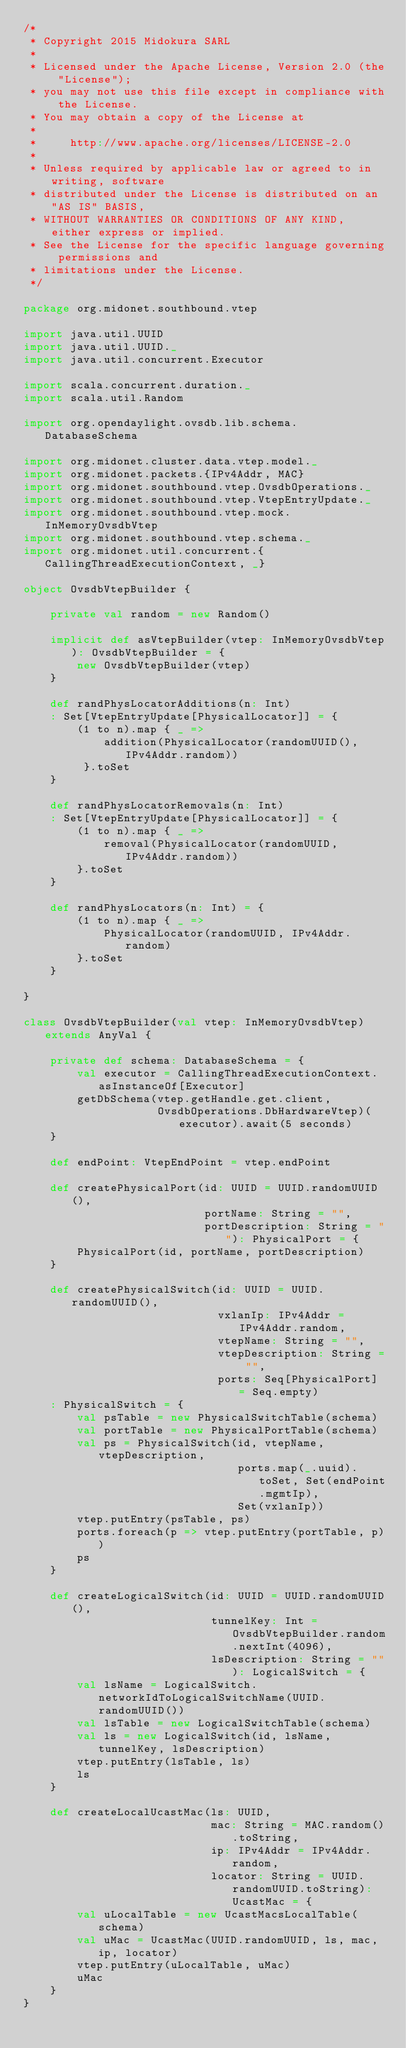Convert code to text. <code><loc_0><loc_0><loc_500><loc_500><_Scala_>/*
 * Copyright 2015 Midokura SARL
 *
 * Licensed under the Apache License, Version 2.0 (the "License");
 * you may not use this file except in compliance with the License.
 * You may obtain a copy of the License at
 *
 *     http://www.apache.org/licenses/LICENSE-2.0
 *
 * Unless required by applicable law or agreed to in writing, software
 * distributed under the License is distributed on an "AS IS" BASIS,
 * WITHOUT WARRANTIES OR CONDITIONS OF ANY KIND, either express or implied.
 * See the License for the specific language governing permissions and
 * limitations under the License.
 */

package org.midonet.southbound.vtep

import java.util.UUID
import java.util.UUID._
import java.util.concurrent.Executor

import scala.concurrent.duration._
import scala.util.Random

import org.opendaylight.ovsdb.lib.schema.DatabaseSchema

import org.midonet.cluster.data.vtep.model._
import org.midonet.packets.{IPv4Addr, MAC}
import org.midonet.southbound.vtep.OvsdbOperations._
import org.midonet.southbound.vtep.VtepEntryUpdate._
import org.midonet.southbound.vtep.mock.InMemoryOvsdbVtep
import org.midonet.southbound.vtep.schema._
import org.midonet.util.concurrent.{CallingThreadExecutionContext, _}

object OvsdbVtepBuilder {

    private val random = new Random()

    implicit def asVtepBuilder(vtep: InMemoryOvsdbVtep): OvsdbVtepBuilder = {
        new OvsdbVtepBuilder(vtep)
    }

    def randPhysLocatorAdditions(n: Int)
    : Set[VtepEntryUpdate[PhysicalLocator]] = {
        (1 to n).map { _ =>
            addition(PhysicalLocator(randomUUID(), IPv4Addr.random))
         }.toSet
    }

    def randPhysLocatorRemovals(n: Int)
    : Set[VtepEntryUpdate[PhysicalLocator]] = {
        (1 to n).map { _ =>
            removal(PhysicalLocator(randomUUID, IPv4Addr.random))
        }.toSet
    }

    def randPhysLocators(n: Int) = {
        (1 to n).map { _ =>
            PhysicalLocator(randomUUID, IPv4Addr.random)
        }.toSet
    }

}

class OvsdbVtepBuilder(val vtep: InMemoryOvsdbVtep) extends AnyVal {

    private def schema: DatabaseSchema = {
        val executor = CallingThreadExecutionContext.asInstanceOf[Executor]
        getDbSchema(vtep.getHandle.get.client,
                    OvsdbOperations.DbHardwareVtep)(executor).await(5 seconds)
    }

    def endPoint: VtepEndPoint = vtep.endPoint

    def createPhysicalPort(id: UUID = UUID.randomUUID(),
                           portName: String = "",
                           portDescription: String = ""): PhysicalPort = {
        PhysicalPort(id, portName, portDescription)
    }

    def createPhysicalSwitch(id: UUID = UUID.randomUUID(),
                             vxlanIp: IPv4Addr = IPv4Addr.random,
                             vtepName: String = "",
                             vtepDescription: String = "",
                             ports: Seq[PhysicalPort] = Seq.empty)
    : PhysicalSwitch = {
        val psTable = new PhysicalSwitchTable(schema)
        val portTable = new PhysicalPortTable(schema)
        val ps = PhysicalSwitch(id, vtepName, vtepDescription,
                                ports.map(_.uuid).toSet, Set(endPoint.mgmtIp),
                                Set(vxlanIp))
        vtep.putEntry(psTable, ps)
        ports.foreach(p => vtep.putEntry(portTable, p))
        ps
    }

    def createLogicalSwitch(id: UUID = UUID.randomUUID(),
                            tunnelKey: Int = OvsdbVtepBuilder.random.nextInt(4096),
                            lsDescription: String = ""): LogicalSwitch = {
        val lsName = LogicalSwitch.networkIdToLogicalSwitchName(UUID.randomUUID())
        val lsTable = new LogicalSwitchTable(schema)
        val ls = new LogicalSwitch(id, lsName, tunnelKey, lsDescription)
        vtep.putEntry(lsTable, ls)
        ls
    }

    def createLocalUcastMac(ls: UUID,
                            mac: String = MAC.random().toString,
                            ip: IPv4Addr = IPv4Addr.random,
                            locator: String = UUID.randomUUID.toString): UcastMac = {
        val uLocalTable = new UcastMacsLocalTable(schema)
        val uMac = UcastMac(UUID.randomUUID, ls, mac, ip, locator)
        vtep.putEntry(uLocalTable, uMac)
        uMac
    }
}
</code> 